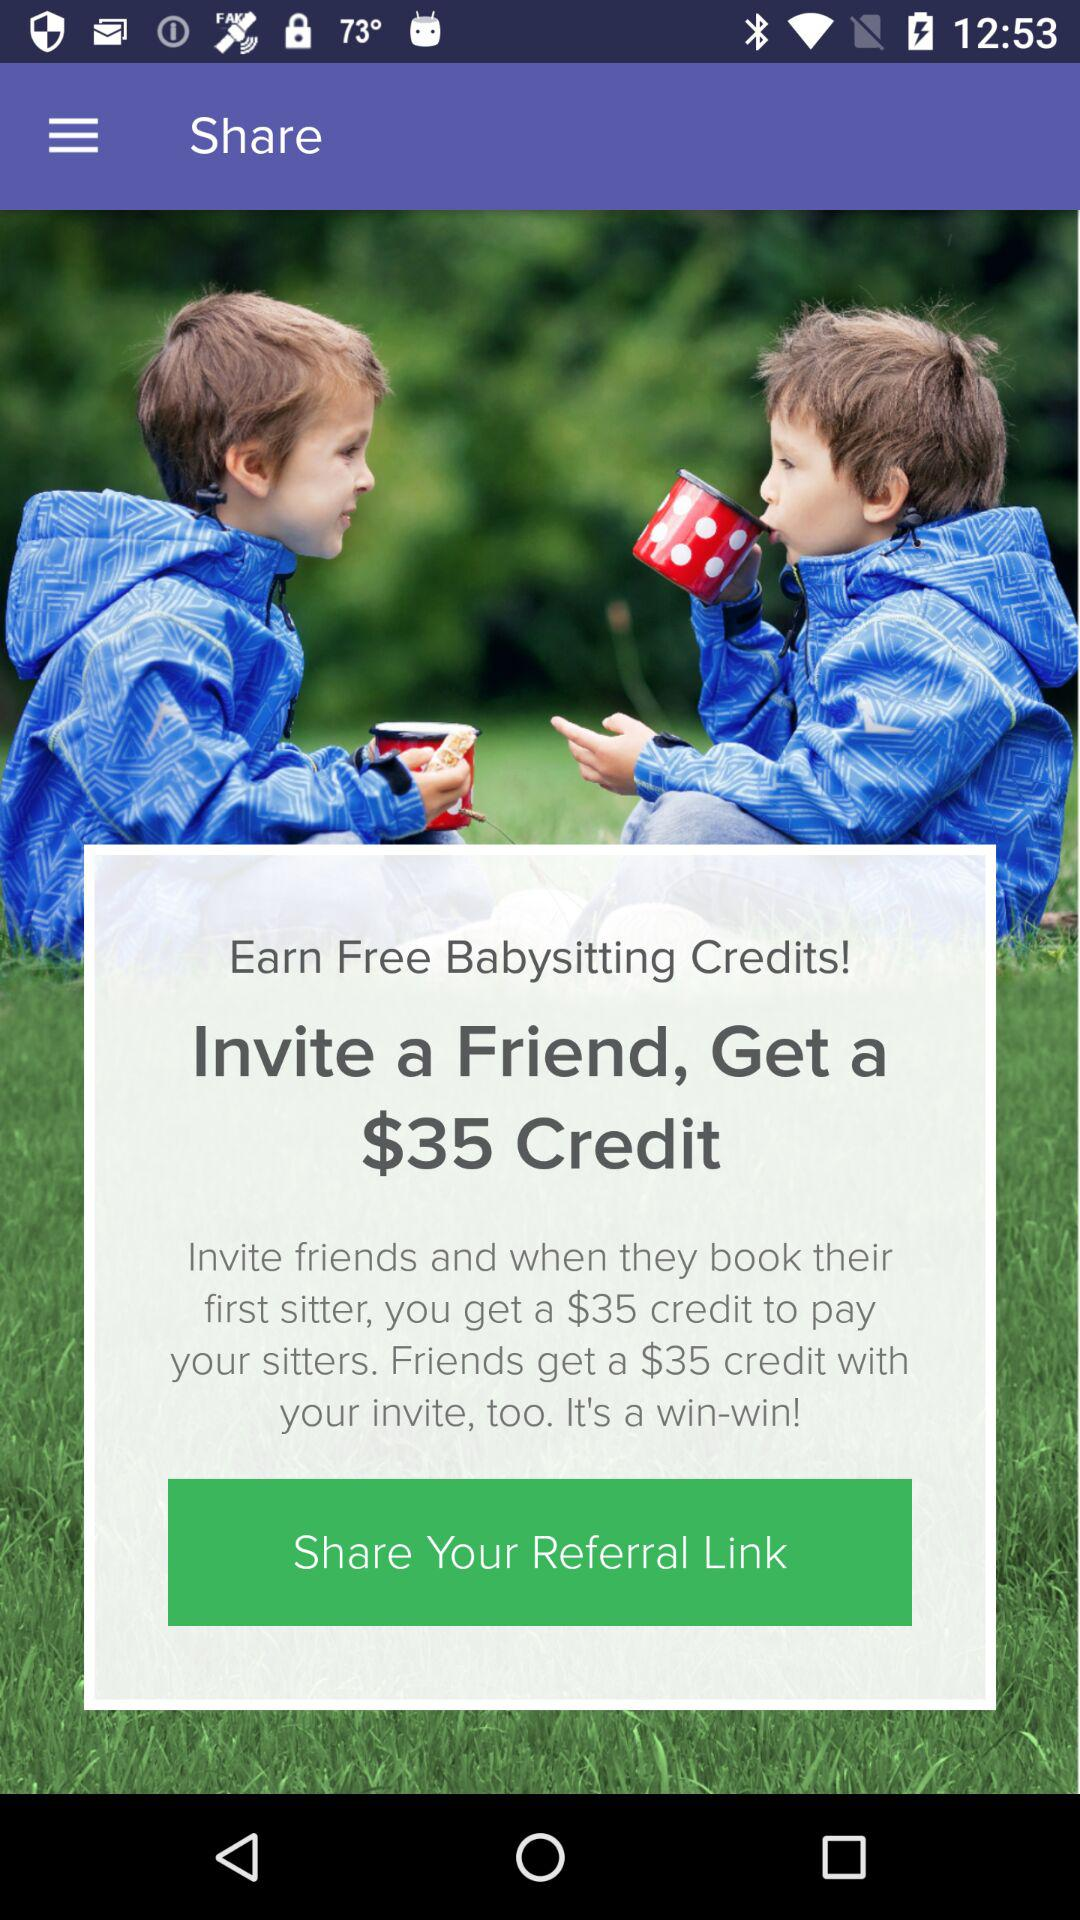How many credits does the user get if they refer a friend who books their first sitter?
Answer the question using a single word or phrase. $35 